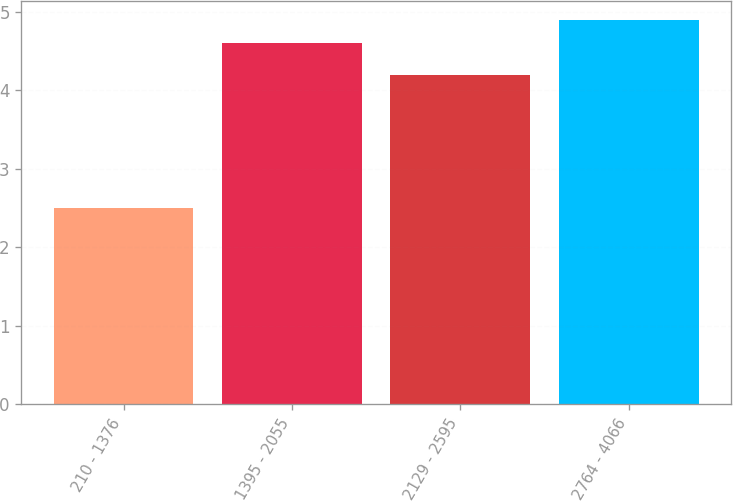Convert chart to OTSL. <chart><loc_0><loc_0><loc_500><loc_500><bar_chart><fcel>210 - 1376<fcel>1395 - 2055<fcel>2129 - 2595<fcel>2764 - 4066<nl><fcel>2.5<fcel>4.6<fcel>4.2<fcel>4.9<nl></chart> 